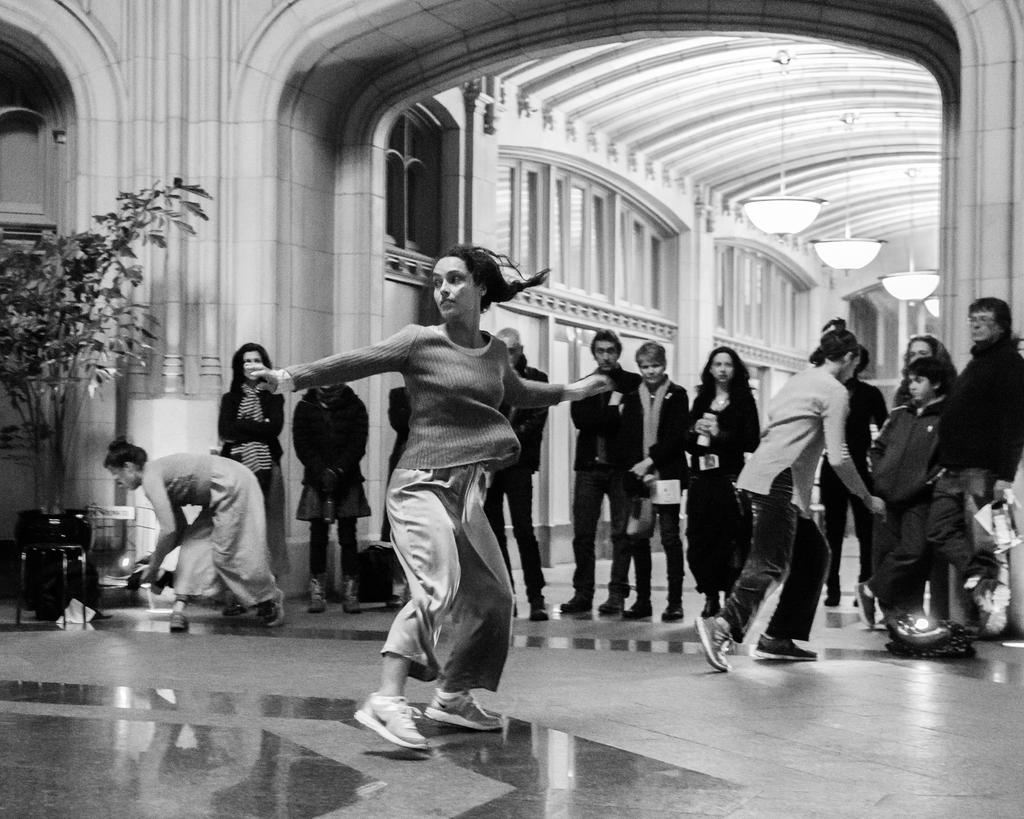What is the main subject of the image? The main subject of the image is a group of people. What can be seen on the left side of the image? There is a plant on the left side of the image. What is visible at the top of the image? There are lights visible at the top of the image. How is the image presented in terms of color? The image is in black and white color. What type of fruit is being held by the person on the right side of the image? There is no fruit visible in the image; it is in black and white color and does not show any fruit. 